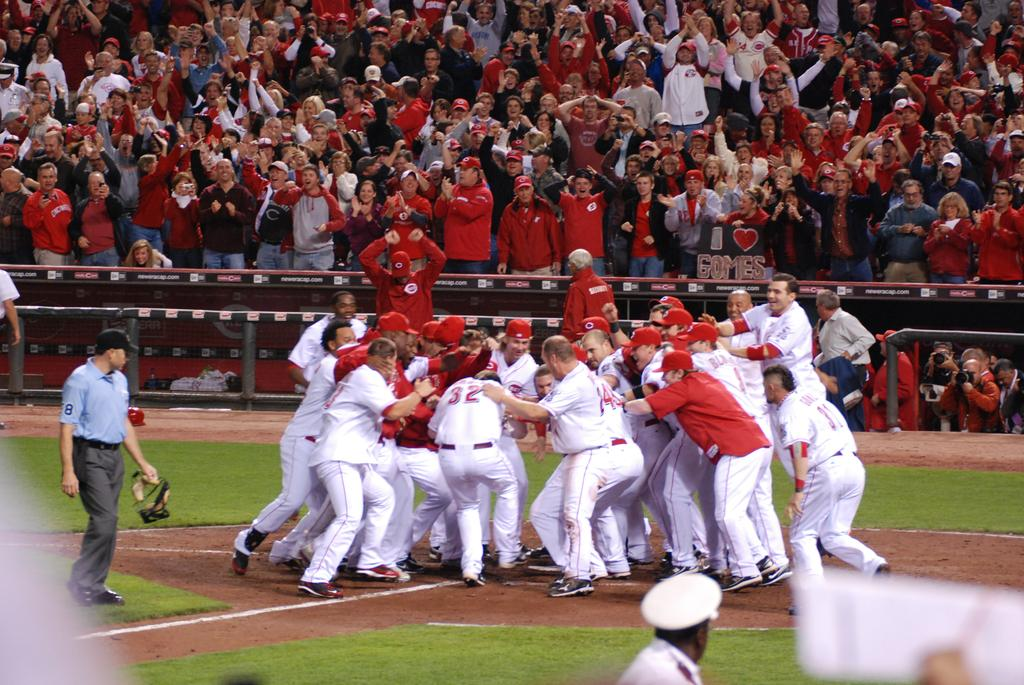<image>
Offer a succinct explanation of the picture presented. a few players celebrating and one with the number 14 on 